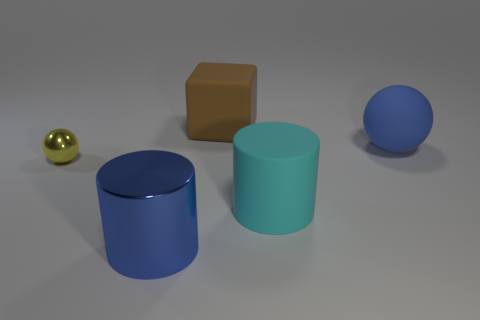Add 2 large green shiny cylinders. How many objects exist? 7 Subtract all balls. How many objects are left? 3 Subtract 0 purple blocks. How many objects are left? 5 Subtract all large yellow metallic blocks. Subtract all big brown matte blocks. How many objects are left? 4 Add 5 rubber cylinders. How many rubber cylinders are left? 6 Add 1 small yellow balls. How many small yellow balls exist? 2 